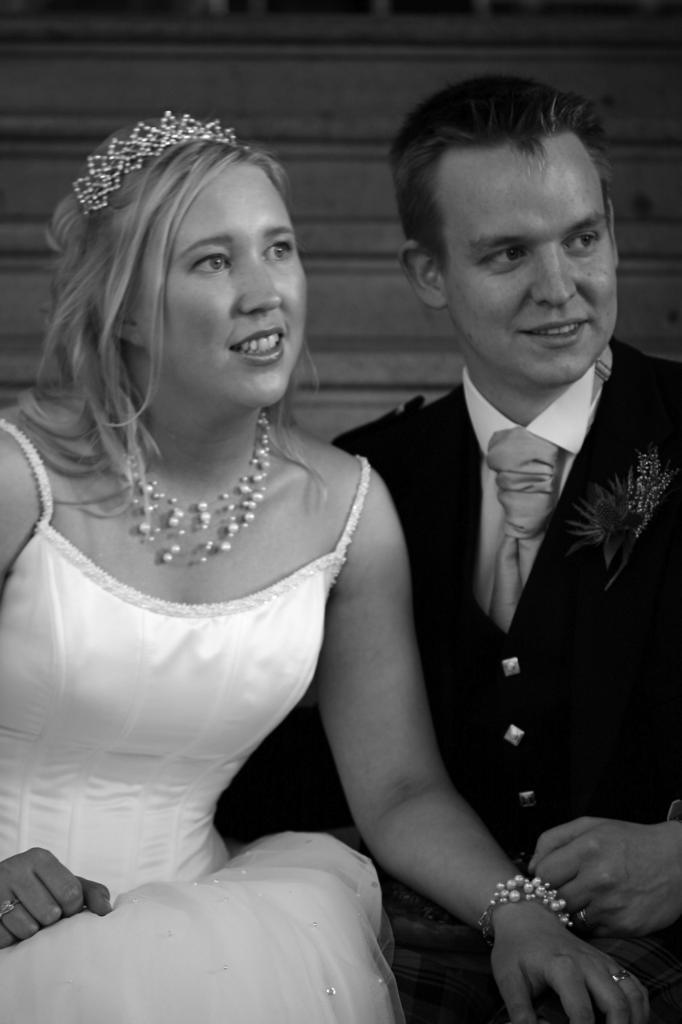Who is the main subject in the image? There is a lady in the image. What is the lady wearing? The lady is wearing a white gown and a crown. Who else is present in the image? There is a man in the image. What is the man wearing? The man is wearing a suit. What can be seen in the background of the image? There are stairs in the background of the image. What type of chin is visible on the lady in the image? There is no chin visible on the lady in the image, as the image only shows her from the neck up. What kind of haircut does the man have in the image? There is no information about the man's haircut in the image, as the focus is on his suit. 